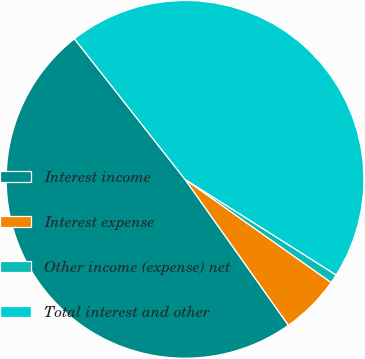Convert chart to OTSL. <chart><loc_0><loc_0><loc_500><loc_500><pie_chart><fcel>Interest income<fcel>Interest expense<fcel>Other income (expense) net<fcel>Total interest and other<nl><fcel>49.2%<fcel>5.41%<fcel>0.8%<fcel>44.59%<nl></chart> 